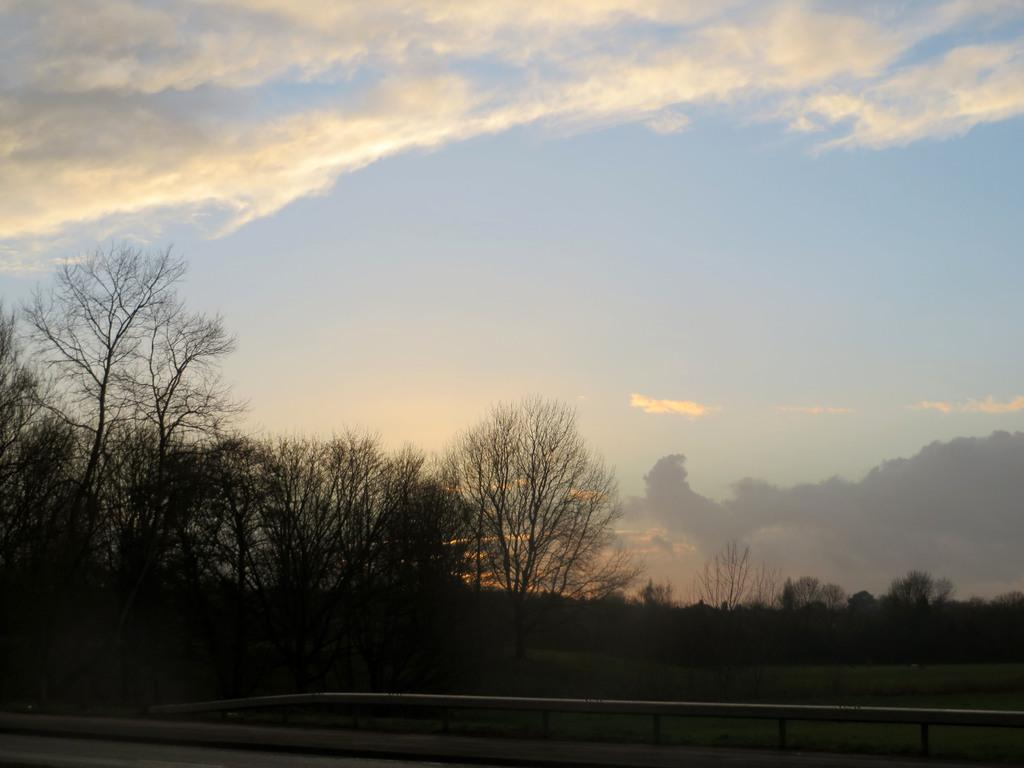What is located at the bottom of the image? There is a fence and a road at the bottom of the image. What can be seen in the background of the image? There are trees, plants, and clouds in the sky in the background of the image. How many minutes does it take for the flower to bloom in the image? There is no flower present in the image, so it is not possible to determine how long it would take for a flower to bloom. 